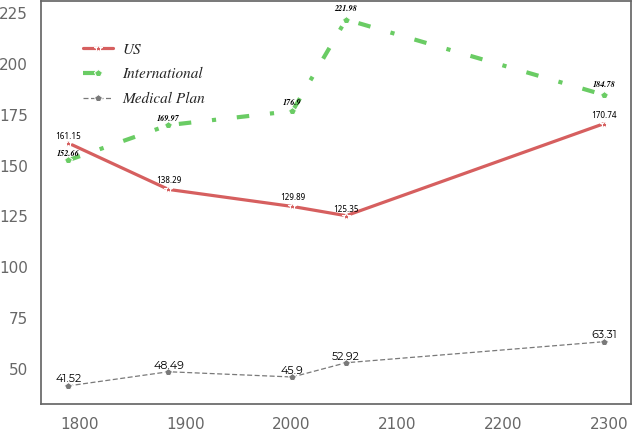<chart> <loc_0><loc_0><loc_500><loc_500><line_chart><ecel><fcel>US<fcel>International<fcel>Medical Plan<nl><fcel>1789.27<fcel>161.15<fcel>152.66<fcel>41.52<nl><fcel>1883.87<fcel>138.29<fcel>169.97<fcel>48.49<nl><fcel>2000.84<fcel>129.89<fcel>176.9<fcel>45.9<nl><fcel>2051.42<fcel>125.35<fcel>221.98<fcel>52.92<nl><fcel>2295.07<fcel>170.74<fcel>184.78<fcel>63.31<nl></chart> 